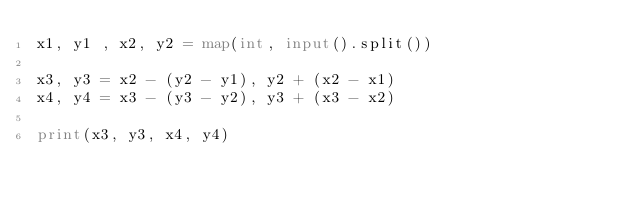<code> <loc_0><loc_0><loc_500><loc_500><_Python_>x1, y1 , x2, y2 = map(int, input().split())

x3, y3 = x2 - (y2 - y1), y2 + (x2 - x1)
x4, y4 = x3 - (y3 - y2), y3 + (x3 - x2)

print(x3, y3, x4, y4)
</code> 